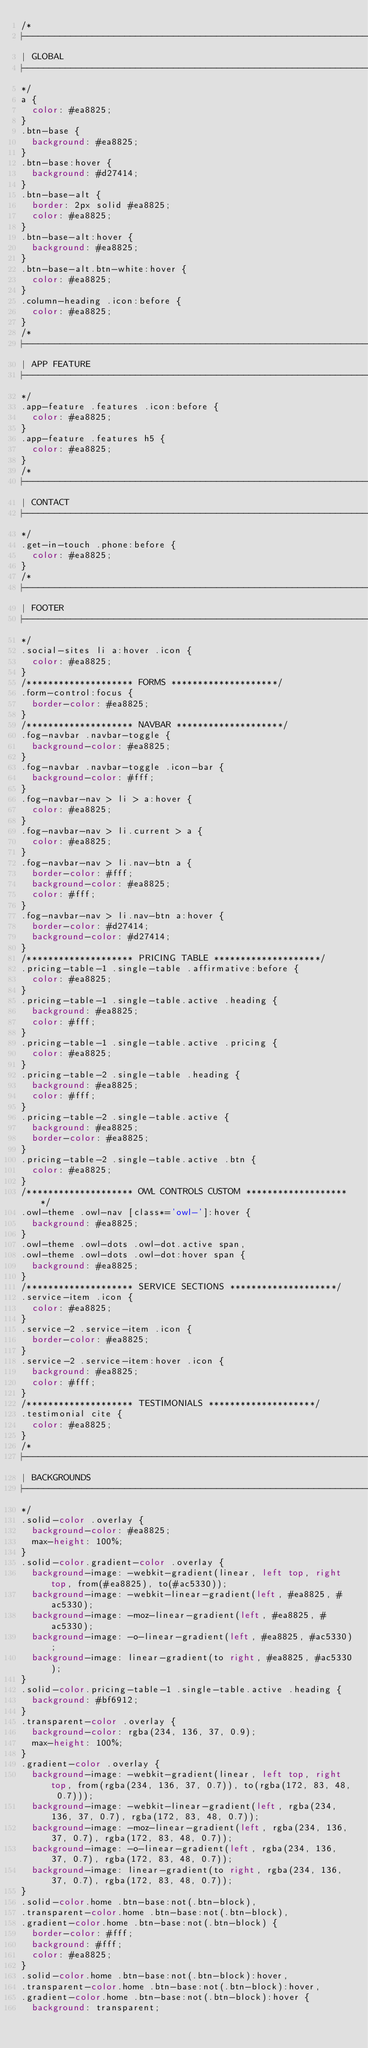<code> <loc_0><loc_0><loc_500><loc_500><_CSS_>/*
|----------------------------------------------------------------------------
| GLOBAL
|----------------------------------------------------------------------------
*/
a {
  color: #ea8825;
}
.btn-base {
  background: #ea8825;
}
.btn-base:hover {
  background: #d27414;
}
.btn-base-alt {
  border: 2px solid #ea8825;
  color: #ea8825;
}
.btn-base-alt:hover {
  background: #ea8825;
}
.btn-base-alt.btn-white:hover {
  color: #ea8825;
}
.column-heading .icon:before {
  color: #ea8825;
}
/*
|----------------------------------------------------------------------------
| APP FEATURE
|----------------------------------------------------------------------------
*/
.app-feature .features .icon:before {
  color: #ea8825;
}
.app-feature .features h5 {
  color: #ea8825;
}
/*
|----------------------------------------------------------------------------
| CONTACT
|----------------------------------------------------------------------------
*/
.get-in-touch .phone:before {
  color: #ea8825;
}
/*
|----------------------------------------------------------------------------
| FOOTER
|----------------------------------------------------------------------------
*/
.social-sites li a:hover .icon {
  color: #ea8825;
}
/******************** FORMS ********************/
.form-control:focus {
  border-color: #ea8825;
}
/******************** NAVBAR ********************/
.fog-navbar .navbar-toggle {
  background-color: #ea8825;
}
.fog-navbar .navbar-toggle .icon-bar {
  background-color: #fff;
}
.fog-navbar-nav > li > a:hover {
  color: #ea8825;
}
.fog-navbar-nav > li.current > a {
  color: #ea8825;
}
.fog-navbar-nav > li.nav-btn a {
  border-color: #fff;
  background-color: #ea8825;
  color: #fff;
}
.fog-navbar-nav > li.nav-btn a:hover {
  border-color: #d27414;
  background-color: #d27414;
}
/******************** PRICING TABLE ********************/
.pricing-table-1 .single-table .affirmative:before {
  color: #ea8825;
}
.pricing-table-1 .single-table.active .heading {
  background: #ea8825;
  color: #fff;
}
.pricing-table-1 .single-table.active .pricing {
  color: #ea8825;
}
.pricing-table-2 .single-table .heading {
  background: #ea8825;
  color: #fff;
}
.pricing-table-2 .single-table.active {
  background: #ea8825;
  border-color: #ea8825;
}
.pricing-table-2 .single-table.active .btn {
  color: #ea8825;
}
/******************** OWL CONTROLS CUSTOM ********************/
.owl-theme .owl-nav [class*='owl-']:hover {
  background: #ea8825;
}
.owl-theme .owl-dots .owl-dot.active span,
.owl-theme .owl-dots .owl-dot:hover span {
  background: #ea8825;
}
/******************** SERVICE SECTIONS ********************/
.service-item .icon {
  color: #ea8825;
}
.service-2 .service-item .icon {
  border-color: #ea8825;
}
.service-2 .service-item:hover .icon {
  background: #ea8825;
  color: #fff;
}
/******************** TESTIMONIALS ********************/
.testimonial cite {
  color: #ea8825;
}
/*
|----------------------------------------------------------------------------
| BACKGROUNDS
|----------------------------------------------------------------------------
*/
.solid-color .overlay {
  background-color: #ea8825;
  max-height: 100%;
}
.solid-color.gradient-color .overlay {
  background-image: -webkit-gradient(linear, left top, right top, from(#ea8825), to(#ac5330));
  background-image: -webkit-linear-gradient(left, #ea8825, #ac5330);
  background-image: -moz-linear-gradient(left, #ea8825, #ac5330);
  background-image: -o-linear-gradient(left, #ea8825, #ac5330);
  background-image: linear-gradient(to right, #ea8825, #ac5330);
}
.solid-color.pricing-table-1 .single-table.active .heading {
  background: #bf6912;
}
.transparent-color .overlay {
  background-color: rgba(234, 136, 37, 0.9);
  max-height: 100%;
}
.gradient-color .overlay {
  background-image: -webkit-gradient(linear, left top, right top, from(rgba(234, 136, 37, 0.7)), to(rgba(172, 83, 48, 0.7)));
  background-image: -webkit-linear-gradient(left, rgba(234, 136, 37, 0.7), rgba(172, 83, 48, 0.7));
  background-image: -moz-linear-gradient(left, rgba(234, 136, 37, 0.7), rgba(172, 83, 48, 0.7));
  background-image: -o-linear-gradient(left, rgba(234, 136, 37, 0.7), rgba(172, 83, 48, 0.7));
  background-image: linear-gradient(to right, rgba(234, 136, 37, 0.7), rgba(172, 83, 48, 0.7));
}
.solid-color.home .btn-base:not(.btn-block),
.transparent-color.home .btn-base:not(.btn-block),
.gradient-color.home .btn-base:not(.btn-block) {
  border-color: #fff;
  background: #fff;
  color: #ea8825;
}
.solid-color.home .btn-base:not(.btn-block):hover,
.transparent-color.home .btn-base:not(.btn-block):hover,
.gradient-color.home .btn-base:not(.btn-block):hover {
  background: transparent;</code> 